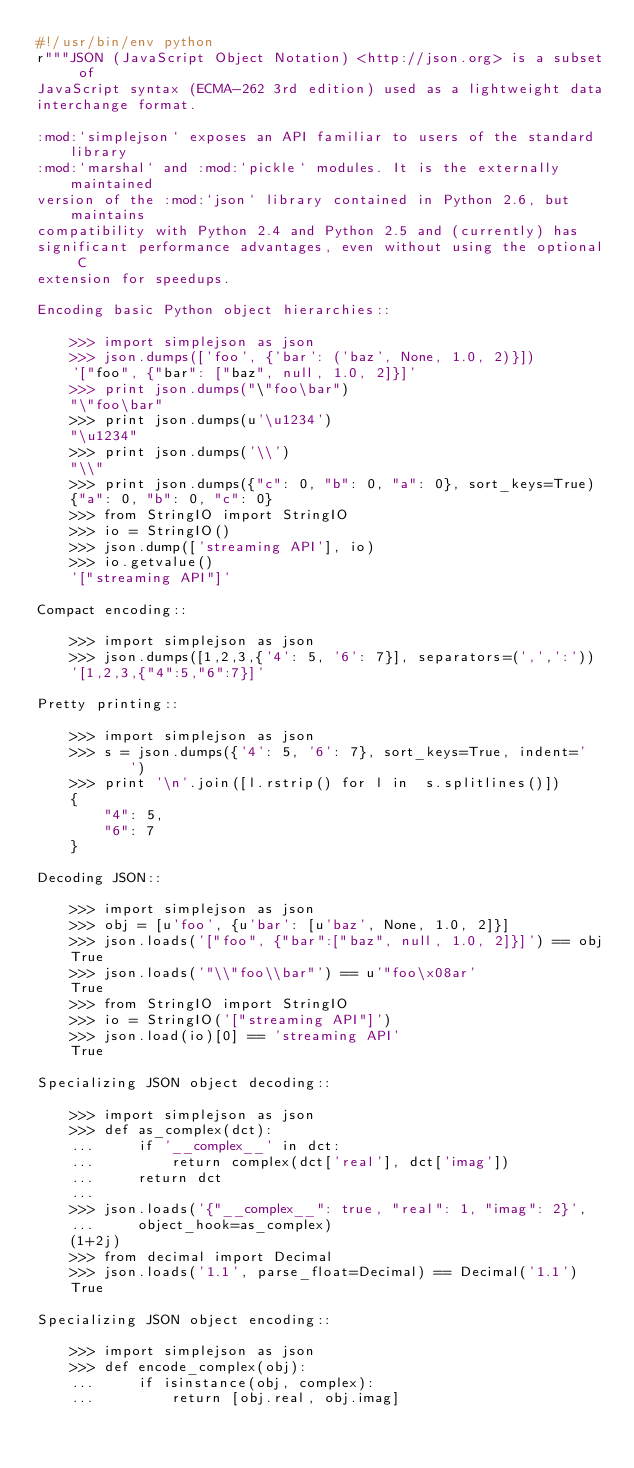<code> <loc_0><loc_0><loc_500><loc_500><_Python_>#!/usr/bin/env python
r"""JSON (JavaScript Object Notation) <http://json.org> is a subset of
JavaScript syntax (ECMA-262 3rd edition) used as a lightweight data
interchange format.

:mod:`simplejson` exposes an API familiar to users of the standard library
:mod:`marshal` and :mod:`pickle` modules. It is the externally maintained
version of the :mod:`json` library contained in Python 2.6, but maintains
compatibility with Python 2.4 and Python 2.5 and (currently) has
significant performance advantages, even without using the optional C
extension for speedups.

Encoding basic Python object hierarchies::

    >>> import simplejson as json
    >>> json.dumps(['foo', {'bar': ('baz', None, 1.0, 2)}])
    '["foo", {"bar": ["baz", null, 1.0, 2]}]'
    >>> print json.dumps("\"foo\bar")
    "\"foo\bar"
    >>> print json.dumps(u'\u1234')
    "\u1234"
    >>> print json.dumps('\\')
    "\\"
    >>> print json.dumps({"c": 0, "b": 0, "a": 0}, sort_keys=True)
    {"a": 0, "b": 0, "c": 0}
    >>> from StringIO import StringIO
    >>> io = StringIO()
    >>> json.dump(['streaming API'], io)
    >>> io.getvalue()
    '["streaming API"]'

Compact encoding::

    >>> import simplejson as json
    >>> json.dumps([1,2,3,{'4': 5, '6': 7}], separators=(',',':'))
    '[1,2,3,{"4":5,"6":7}]'

Pretty printing::

    >>> import simplejson as json
    >>> s = json.dumps({'4': 5, '6': 7}, sort_keys=True, indent='    ')
    >>> print '\n'.join([l.rstrip() for l in  s.splitlines()])
    {
        "4": 5,
        "6": 7
    }

Decoding JSON::

    >>> import simplejson as json
    >>> obj = [u'foo', {u'bar': [u'baz', None, 1.0, 2]}]
    >>> json.loads('["foo", {"bar":["baz", null, 1.0, 2]}]') == obj
    True
    >>> json.loads('"\\"foo\\bar"') == u'"foo\x08ar'
    True
    >>> from StringIO import StringIO
    >>> io = StringIO('["streaming API"]')
    >>> json.load(io)[0] == 'streaming API'
    True

Specializing JSON object decoding::

    >>> import simplejson as json
    >>> def as_complex(dct):
    ...     if '__complex__' in dct:
    ...         return complex(dct['real'], dct['imag'])
    ...     return dct
    ...
    >>> json.loads('{"__complex__": true, "real": 1, "imag": 2}',
    ...     object_hook=as_complex)
    (1+2j)
    >>> from decimal import Decimal
    >>> json.loads('1.1', parse_float=Decimal) == Decimal('1.1')
    True

Specializing JSON object encoding::

    >>> import simplejson as json
    >>> def encode_complex(obj):
    ...     if isinstance(obj, complex):
    ...         return [obj.real, obj.imag]</code> 